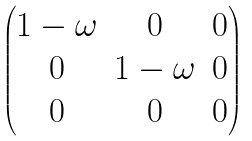Convert formula to latex. <formula><loc_0><loc_0><loc_500><loc_500>\begin{pmatrix} 1 - \omega & 0 & 0 \\ 0 & 1 - \omega & 0 \\ 0 & 0 & 0 \end{pmatrix}</formula> 